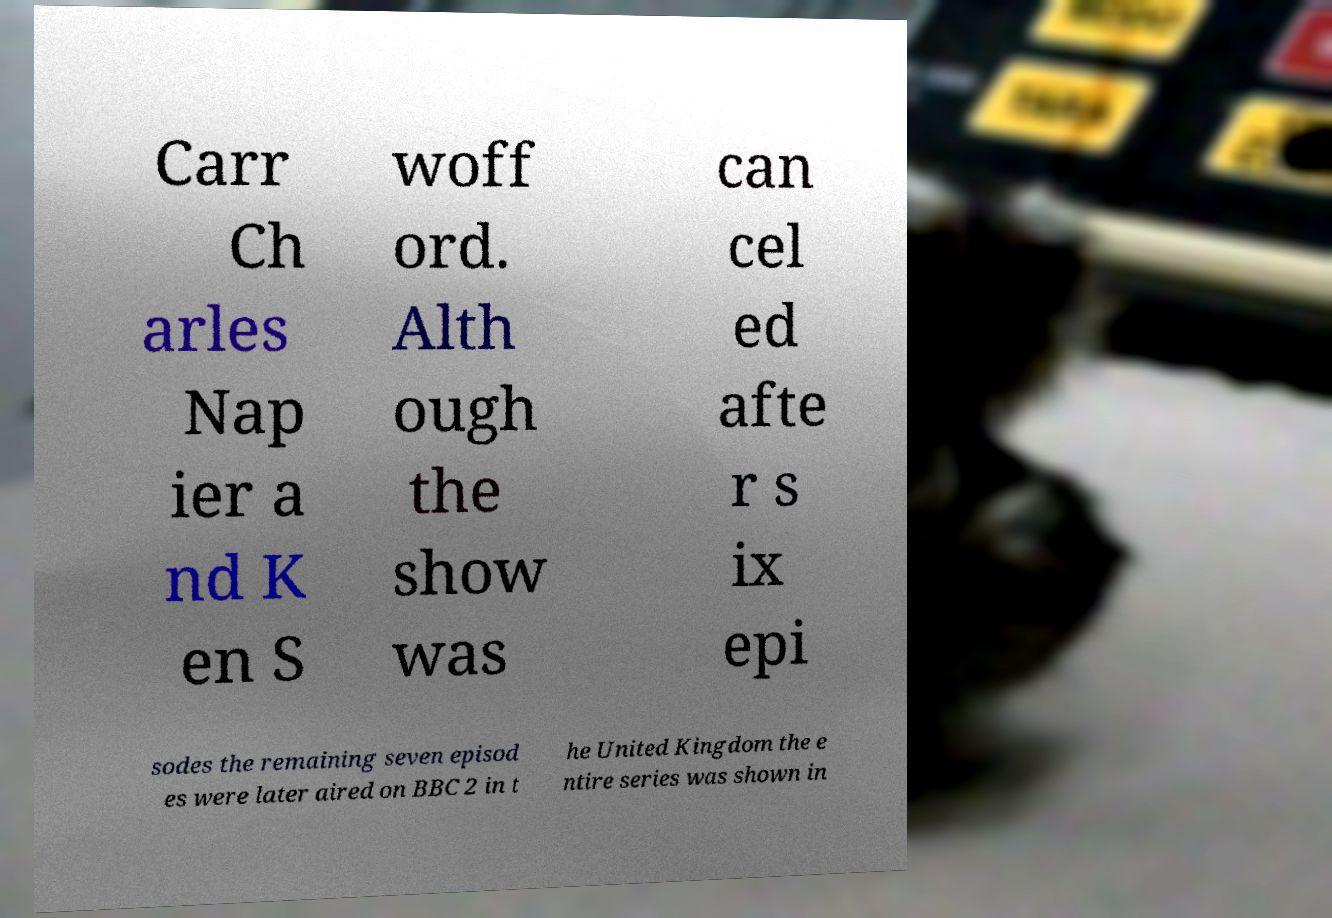Can you accurately transcribe the text from the provided image for me? Carr Ch arles Nap ier a nd K en S woff ord. Alth ough the show was can cel ed afte r s ix epi sodes the remaining seven episod es were later aired on BBC 2 in t he United Kingdom the e ntire series was shown in 